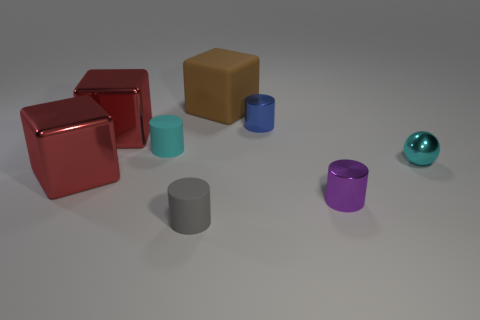Which object looks the shiniest? The shiniest object appears to be the small spherical object on the far right, exhibiting a reflective teal surface. What material could that object be made of, based on its shine? Based on its highly reflective surface and shine, that object could be made of a polished metal or a similar reflective material like smooth glass. 